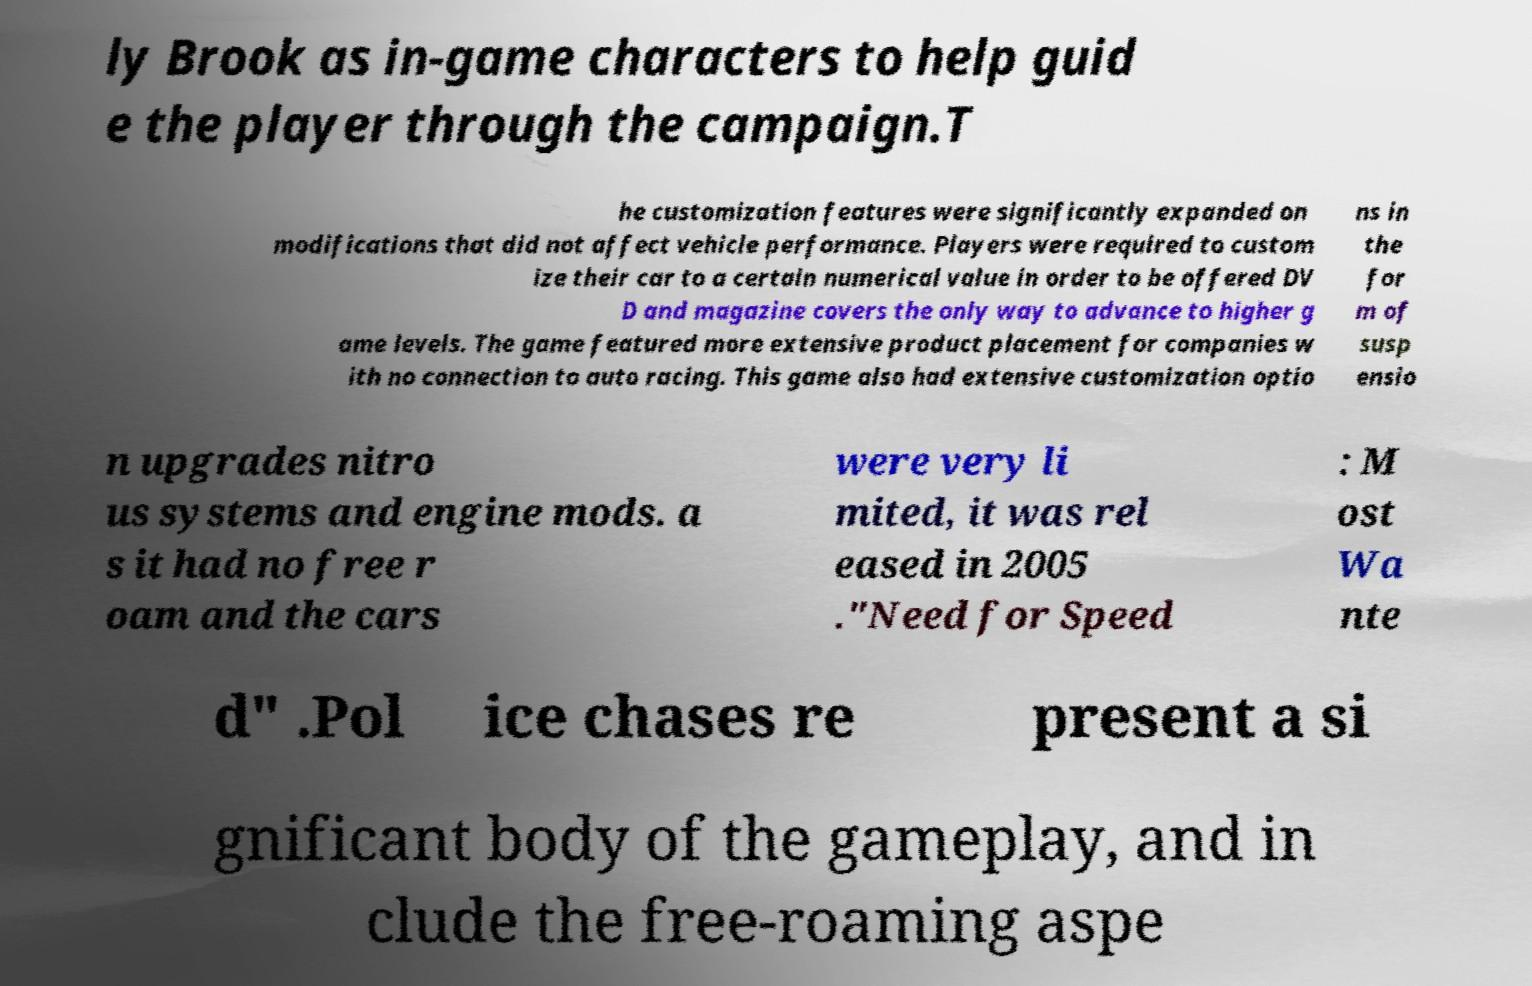For documentation purposes, I need the text within this image transcribed. Could you provide that? ly Brook as in-game characters to help guid e the player through the campaign.T he customization features were significantly expanded on modifications that did not affect vehicle performance. Players were required to custom ize their car to a certain numerical value in order to be offered DV D and magazine covers the only way to advance to higher g ame levels. The game featured more extensive product placement for companies w ith no connection to auto racing. This game also had extensive customization optio ns in the for m of susp ensio n upgrades nitro us systems and engine mods. a s it had no free r oam and the cars were very li mited, it was rel eased in 2005 ."Need for Speed : M ost Wa nte d" .Pol ice chases re present a si gnificant body of the gameplay, and in clude the free-roaming aspe 